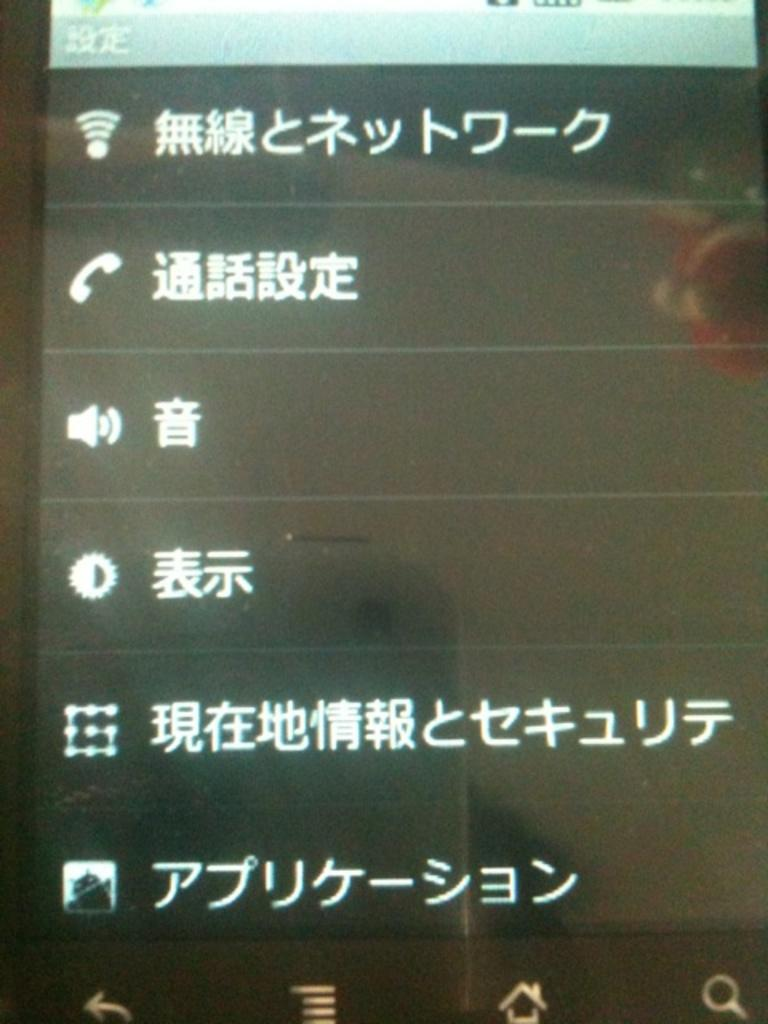What is the color of the mobile screen in the image? The mobile screen is black in color. What can be seen on the mobile screen? There are white-colored words on the mobile screen. Are there any additional elements at the bottom of the image? Yes, there are symbols at the bottom of the image. Can you describe the texture of the horse in the image? There is no horse present in the image, so it is not possible to describe its texture. 